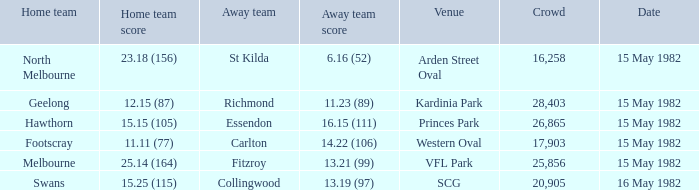Which team, when playing away against melbourne, had a crowd of over 17,903 spectators? 13.21 (99). 